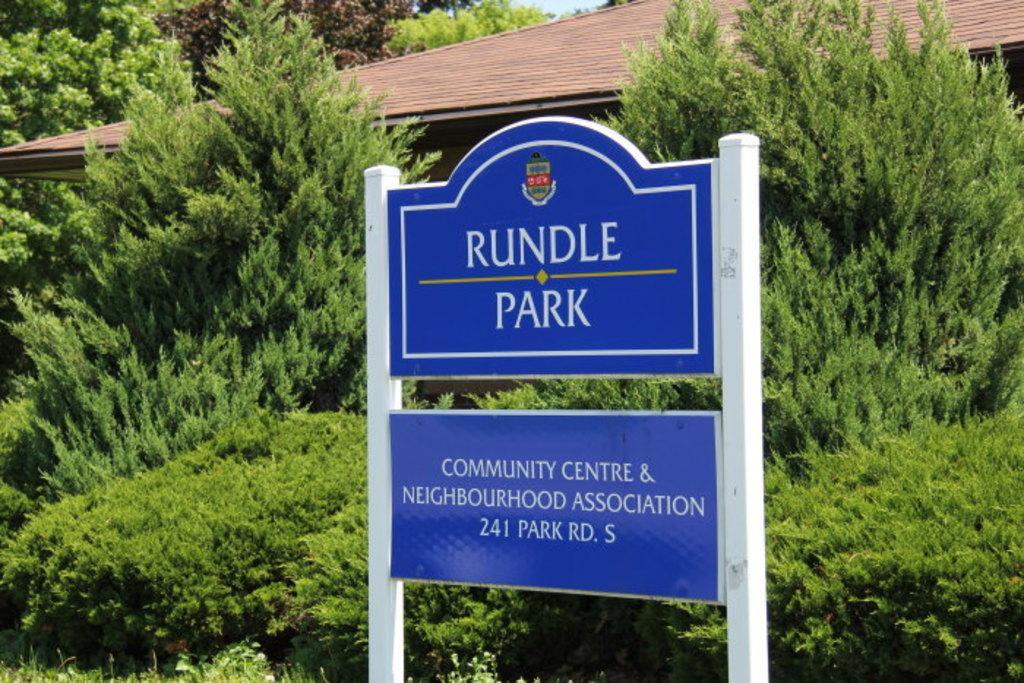Describe this image in one or two sentences. In the foreground of the picture there is a board. In center of the picture there are plants, trees and a house. In the background there are trees. 